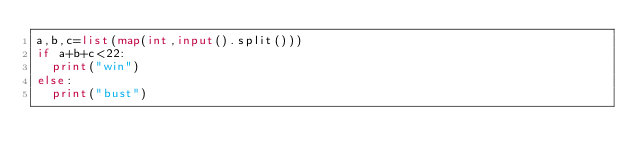Convert code to text. <code><loc_0><loc_0><loc_500><loc_500><_Python_>a,b,c=list(map(int,input().split()))
if a+b+c<22:
  print("win")
else:
  print("bust")</code> 